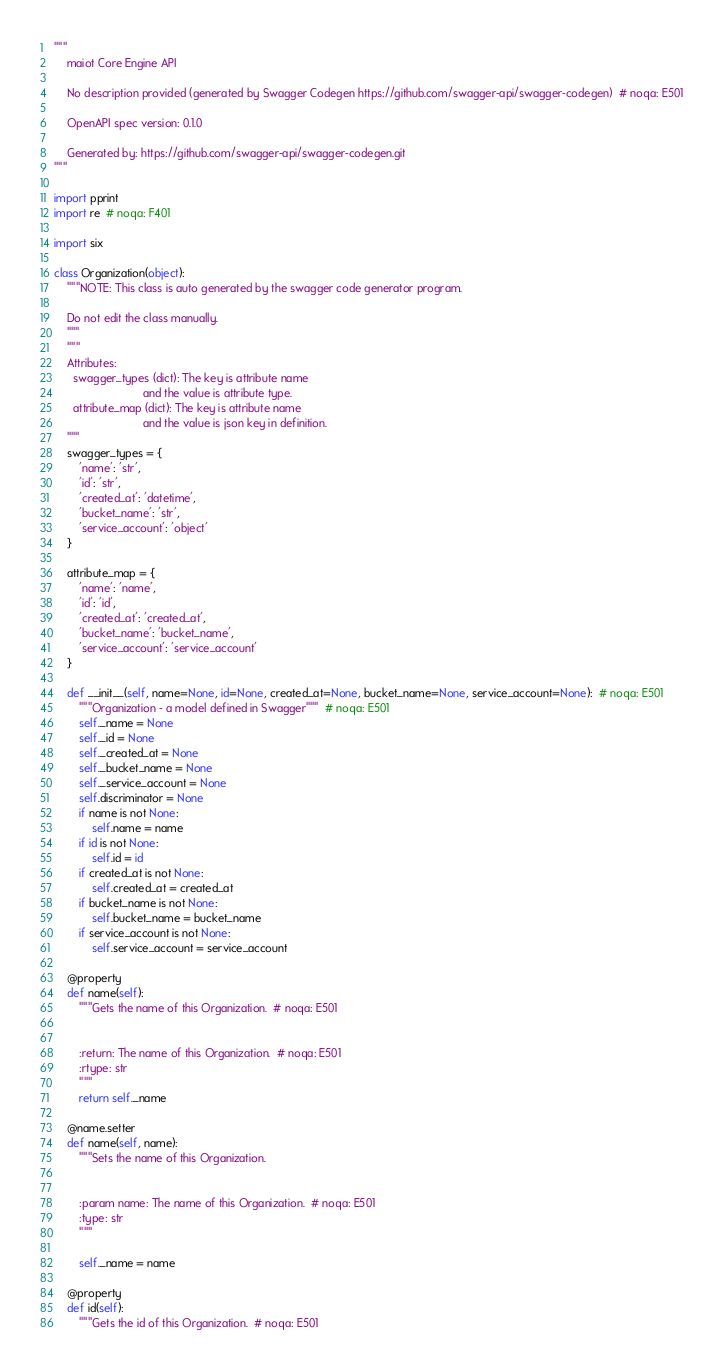Convert code to text. <code><loc_0><loc_0><loc_500><loc_500><_Python_>"""
    maiot Core Engine API

    No description provided (generated by Swagger Codegen https://github.com/swagger-api/swagger-codegen)  # noqa: E501

    OpenAPI spec version: 0.1.0
    
    Generated by: https://github.com/swagger-api/swagger-codegen.git
"""

import pprint
import re  # noqa: F401

import six

class Organization(object):
    """NOTE: This class is auto generated by the swagger code generator program.

    Do not edit the class manually.
    """
    """
    Attributes:
      swagger_types (dict): The key is attribute name
                            and the value is attribute type.
      attribute_map (dict): The key is attribute name
                            and the value is json key in definition.
    """
    swagger_types = {
        'name': 'str',
        'id': 'str',
        'created_at': 'datetime',
        'bucket_name': 'str',
        'service_account': 'object'
    }

    attribute_map = {
        'name': 'name',
        'id': 'id',
        'created_at': 'created_at',
        'bucket_name': 'bucket_name',
        'service_account': 'service_account'
    }

    def __init__(self, name=None, id=None, created_at=None, bucket_name=None, service_account=None):  # noqa: E501
        """Organization - a model defined in Swagger"""  # noqa: E501
        self._name = None
        self._id = None
        self._created_at = None
        self._bucket_name = None
        self._service_account = None
        self.discriminator = None
        if name is not None:
            self.name = name
        if id is not None:
            self.id = id
        if created_at is not None:
            self.created_at = created_at
        if bucket_name is not None:
            self.bucket_name = bucket_name
        if service_account is not None:
            self.service_account = service_account

    @property
    def name(self):
        """Gets the name of this Organization.  # noqa: E501


        :return: The name of this Organization.  # noqa: E501
        :rtype: str
        """
        return self._name

    @name.setter
    def name(self, name):
        """Sets the name of this Organization.


        :param name: The name of this Organization.  # noqa: E501
        :type: str
        """

        self._name = name

    @property
    def id(self):
        """Gets the id of this Organization.  # noqa: E501

</code> 